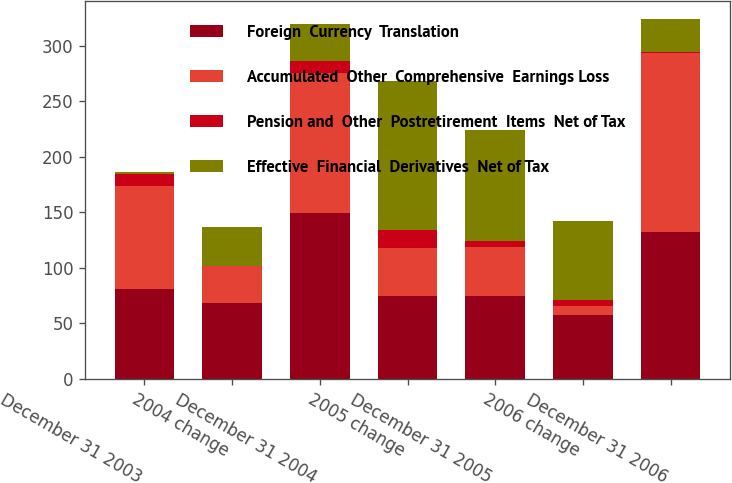<chart> <loc_0><loc_0><loc_500><loc_500><stacked_bar_chart><ecel><fcel>December 31 2003<fcel>2004 change<fcel>December 31 2004<fcel>2005 change<fcel>December 31 2005<fcel>2006 change<fcel>December 31 2006<nl><fcel>Foreign  Currency  Translation<fcel>80.7<fcel>68.2<fcel>148.9<fcel>74.3<fcel>74.6<fcel>57.2<fcel>131.8<nl><fcel>Accumulated  Other  Comprehensive  Earnings Loss<fcel>93.1<fcel>33.2<fcel>126.3<fcel>43.6<fcel>43.6<fcel>8<fcel>161.9<nl><fcel>Pension and  Other  Postretirement  Items  Net of Tax<fcel>11<fcel>0.4<fcel>10.6<fcel>16<fcel>5.4<fcel>6<fcel>0.6<nl><fcel>Effective  Financial  Derivatives  Net of Tax<fcel>1.4<fcel>34.6<fcel>33.2<fcel>133.9<fcel>100.7<fcel>71.2<fcel>29.5<nl></chart> 